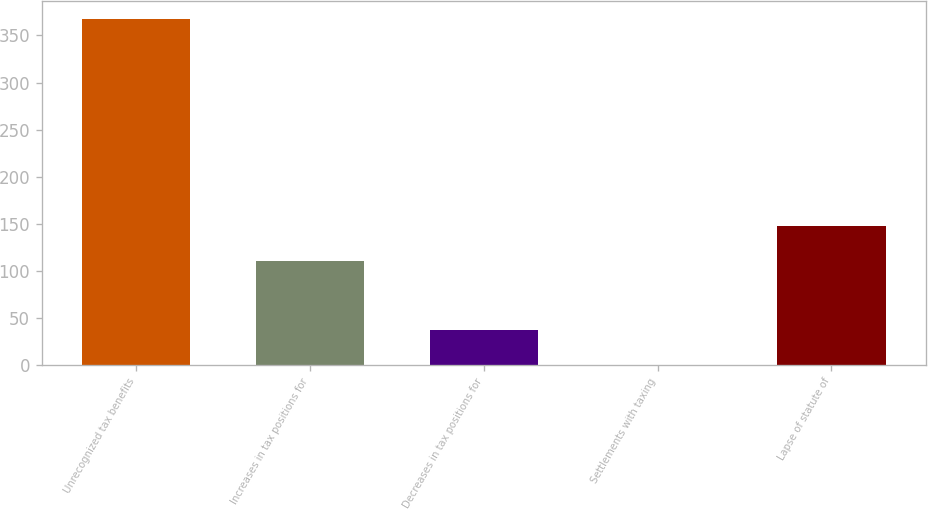Convert chart. <chart><loc_0><loc_0><loc_500><loc_500><bar_chart><fcel>Unrecognized tax benefits<fcel>Increases in tax positions for<fcel>Decreases in tax positions for<fcel>Settlements with taxing<fcel>Lapse of statute of<nl><fcel>367.9<fcel>110.44<fcel>36.88<fcel>0.1<fcel>147.22<nl></chart> 